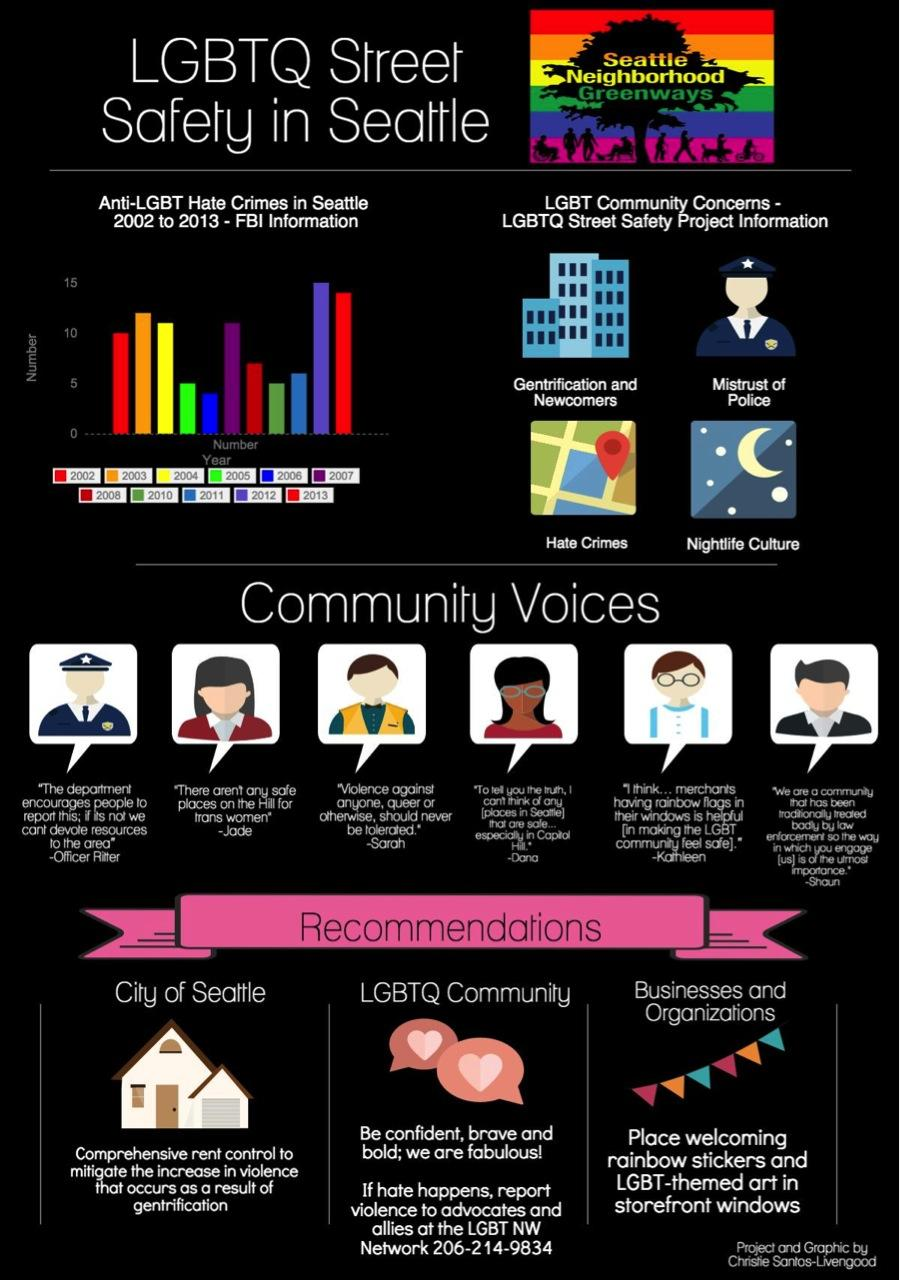Point out several critical features in this image. In 2005, the anti-LGBT hate crime in Seattle was the second lowest recorded. There have been a total of 3 recommendations mentioned. 